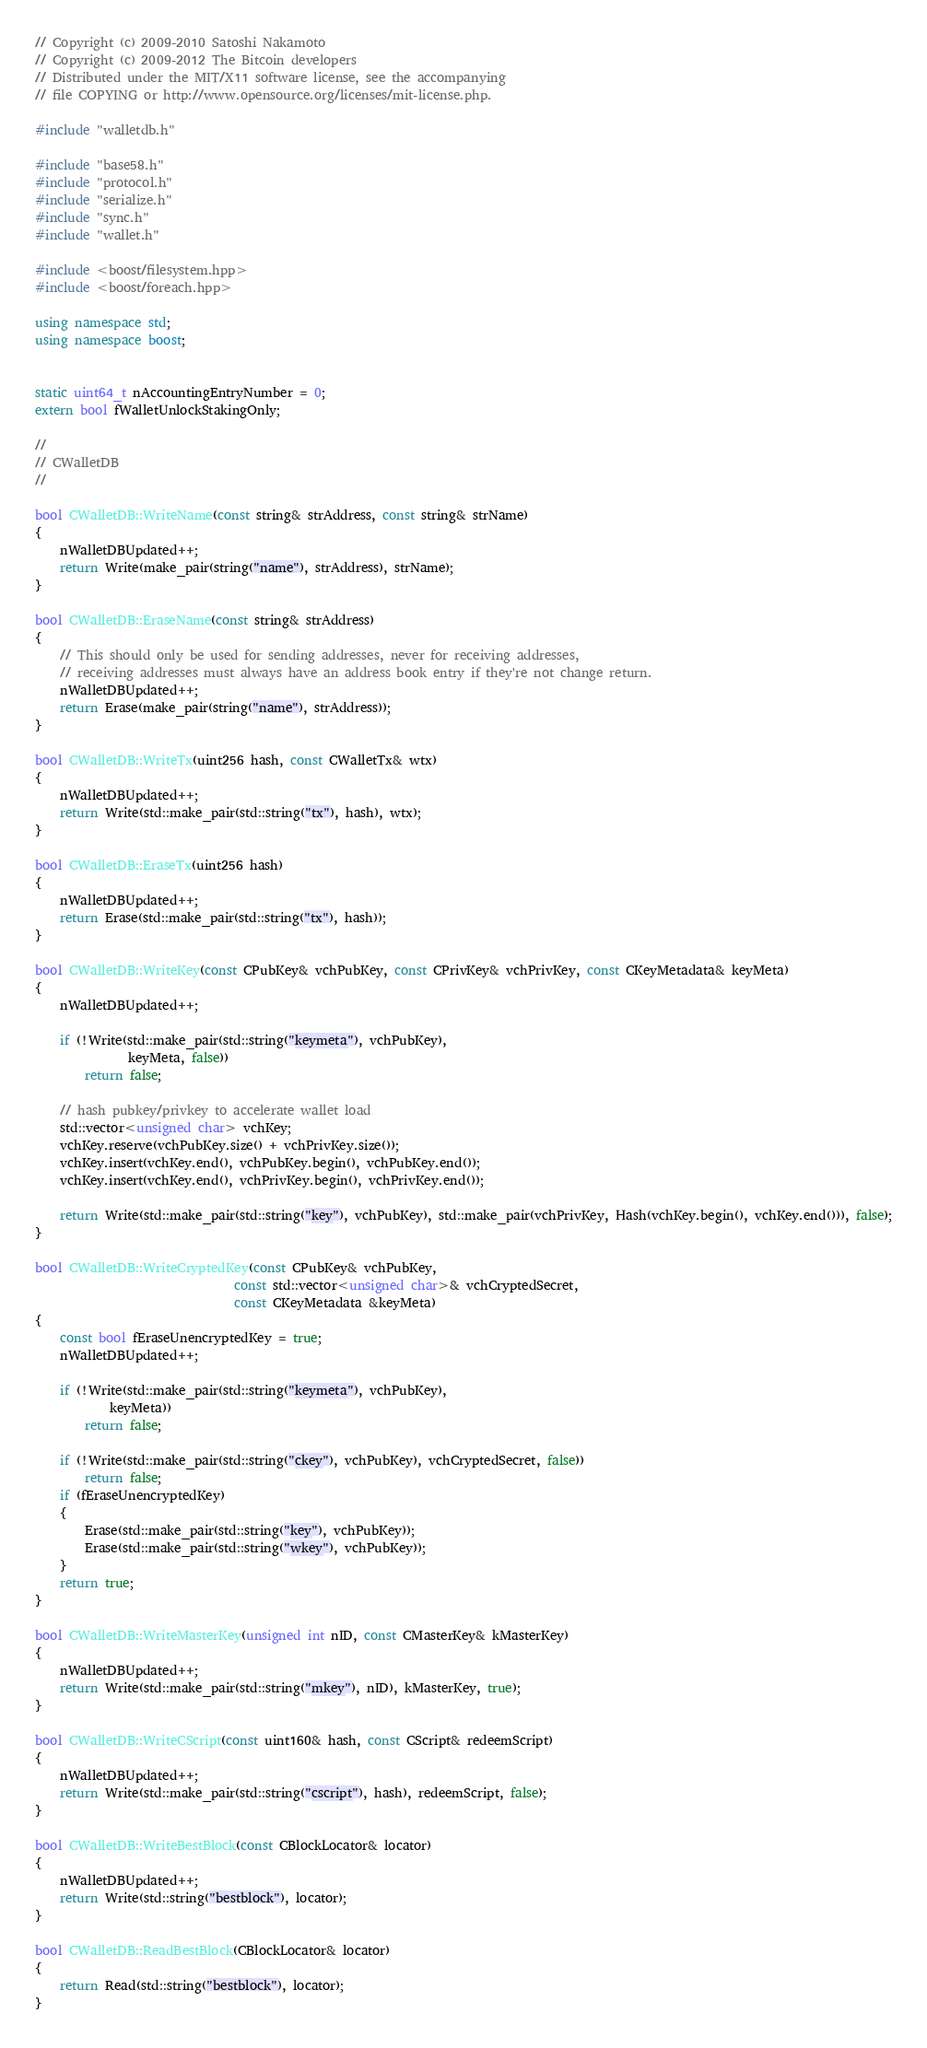Convert code to text. <code><loc_0><loc_0><loc_500><loc_500><_C++_>// Copyright (c) 2009-2010 Satoshi Nakamoto
// Copyright (c) 2009-2012 The Bitcoin developers
// Distributed under the MIT/X11 software license, see the accompanying
// file COPYING or http://www.opensource.org/licenses/mit-license.php.

#include "walletdb.h"

#include "base58.h"
#include "protocol.h"
#include "serialize.h"
#include "sync.h"
#include "wallet.h"

#include <boost/filesystem.hpp>
#include <boost/foreach.hpp>

using namespace std;
using namespace boost;


static uint64_t nAccountingEntryNumber = 0;
extern bool fWalletUnlockStakingOnly;

//
// CWalletDB
//

bool CWalletDB::WriteName(const string& strAddress, const string& strName)
{
    nWalletDBUpdated++;
    return Write(make_pair(string("name"), strAddress), strName);
}

bool CWalletDB::EraseName(const string& strAddress)
{
    // This should only be used for sending addresses, never for receiving addresses,
    // receiving addresses must always have an address book entry if they're not change return.
    nWalletDBUpdated++;
    return Erase(make_pair(string("name"), strAddress));
}

bool CWalletDB::WriteTx(uint256 hash, const CWalletTx& wtx)
{
    nWalletDBUpdated++;
    return Write(std::make_pair(std::string("tx"), hash), wtx);
}

bool CWalletDB::EraseTx(uint256 hash)
{
    nWalletDBUpdated++;
    return Erase(std::make_pair(std::string("tx"), hash));
}

bool CWalletDB::WriteKey(const CPubKey& vchPubKey, const CPrivKey& vchPrivKey, const CKeyMetadata& keyMeta)
{
    nWalletDBUpdated++;

    if (!Write(std::make_pair(std::string("keymeta"), vchPubKey),
               keyMeta, false))
        return false;

    // hash pubkey/privkey to accelerate wallet load
    std::vector<unsigned char> vchKey;
    vchKey.reserve(vchPubKey.size() + vchPrivKey.size());
    vchKey.insert(vchKey.end(), vchPubKey.begin(), vchPubKey.end());
    vchKey.insert(vchKey.end(), vchPrivKey.begin(), vchPrivKey.end());

    return Write(std::make_pair(std::string("key"), vchPubKey), std::make_pair(vchPrivKey, Hash(vchKey.begin(), vchKey.end())), false);
}

bool CWalletDB::WriteCryptedKey(const CPubKey& vchPubKey,
                                const std::vector<unsigned char>& vchCryptedSecret,
                                const CKeyMetadata &keyMeta)
{
    const bool fEraseUnencryptedKey = true;
    nWalletDBUpdated++;

    if (!Write(std::make_pair(std::string("keymeta"), vchPubKey),
            keyMeta))
        return false;

    if (!Write(std::make_pair(std::string("ckey"), vchPubKey), vchCryptedSecret, false))
        return false;
    if (fEraseUnencryptedKey)
    {
        Erase(std::make_pair(std::string("key"), vchPubKey));
        Erase(std::make_pair(std::string("wkey"), vchPubKey));
    }
    return true;
}

bool CWalletDB::WriteMasterKey(unsigned int nID, const CMasterKey& kMasterKey)
{
    nWalletDBUpdated++;
    return Write(std::make_pair(std::string("mkey"), nID), kMasterKey, true);
}

bool CWalletDB::WriteCScript(const uint160& hash, const CScript& redeemScript)
{
    nWalletDBUpdated++;
    return Write(std::make_pair(std::string("cscript"), hash), redeemScript, false);
}

bool CWalletDB::WriteBestBlock(const CBlockLocator& locator)
{
    nWalletDBUpdated++;
    return Write(std::string("bestblock"), locator);
}

bool CWalletDB::ReadBestBlock(CBlockLocator& locator)
{
    return Read(std::string("bestblock"), locator);
}
</code> 